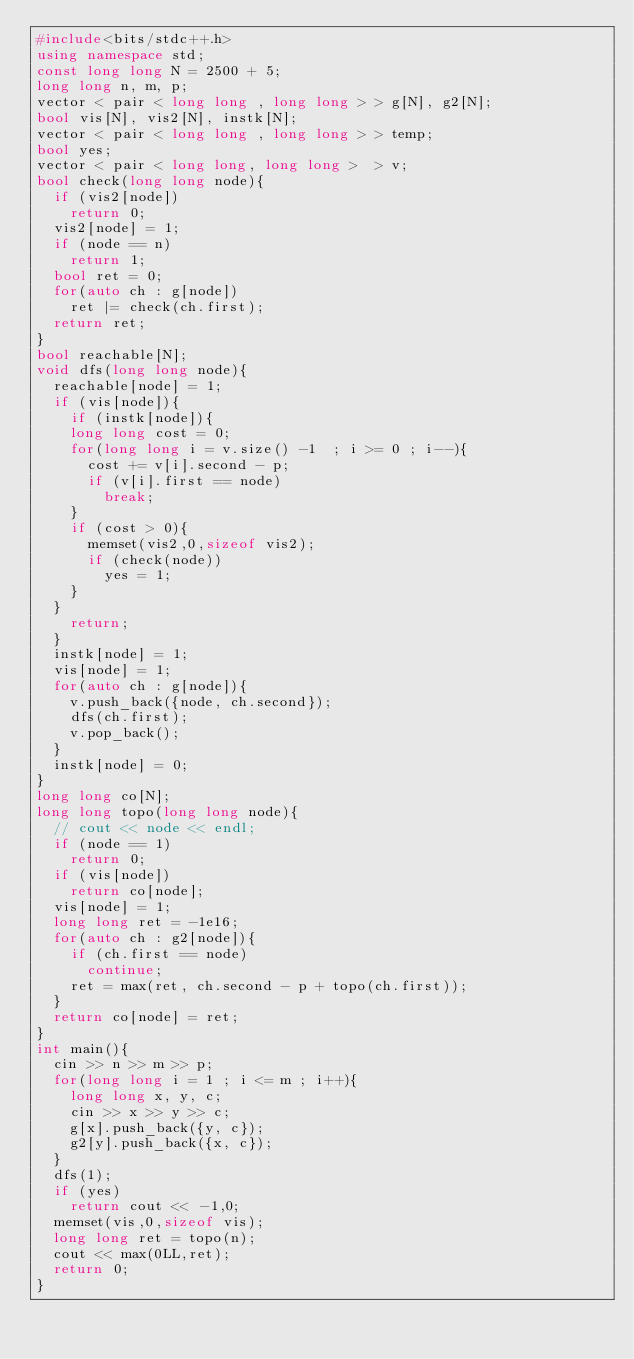<code> <loc_0><loc_0><loc_500><loc_500><_C++_>#include<bits/stdc++.h>
using namespace std;
const long long N = 2500 + 5;
long long n, m, p;
vector < pair < long long , long long > > g[N], g2[N];
bool vis[N], vis2[N], instk[N];
vector < pair < long long , long long > > temp;
bool yes;
vector < pair < long long, long long >  > v;
bool check(long long node){
  if (vis2[node])
    return 0;
  vis2[node] = 1;
  if (node == n)
    return 1;
  bool ret = 0;
  for(auto ch : g[node])
    ret |= check(ch.first);
  return ret;
}
bool reachable[N];
void dfs(long long node){
  reachable[node] = 1;
  if (vis[node]){
    if (instk[node]){
    long long cost = 0;
    for(long long i = v.size() -1  ; i >= 0 ; i--){
      cost += v[i].second - p;
      if (v[i].first == node)
        break;
    }
    if (cost > 0){
      memset(vis2,0,sizeof vis2);
      if (check(node))
        yes = 1;
    }
  }
    return;
  }
  instk[node] = 1;
  vis[node] = 1;
  for(auto ch : g[node]){
    v.push_back({node, ch.second});
    dfs(ch.first);
    v.pop_back();
  }
  instk[node] = 0;
}
long long co[N];
long long topo(long long node){
  // cout << node << endl;
  if (node == 1)
    return 0;
  if (vis[node])
    return co[node];
  vis[node] = 1;
  long long ret = -1e16;
  for(auto ch : g2[node]){
    if (ch.first == node)
      continue;
    ret = max(ret, ch.second - p + topo(ch.first));
  }
  return co[node] = ret;
}
int main(){
  cin >> n >> m >> p;
  for(long long i = 1 ; i <= m ; i++){
    long long x, y, c;
    cin >> x >> y >> c;
    g[x].push_back({y, c});
    g2[y].push_back({x, c});
  }
  dfs(1);
  if (yes)
    return cout << -1,0;
  memset(vis,0,sizeof vis);
  long long ret = topo(n);
  cout << max(0LL,ret);
  return 0;
}
</code> 